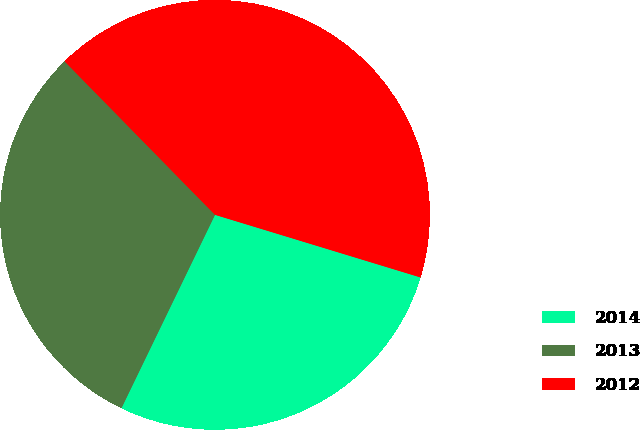Convert chart to OTSL. <chart><loc_0><loc_0><loc_500><loc_500><pie_chart><fcel>2014<fcel>2013<fcel>2012<nl><fcel>27.47%<fcel>30.49%<fcel>42.05%<nl></chart> 